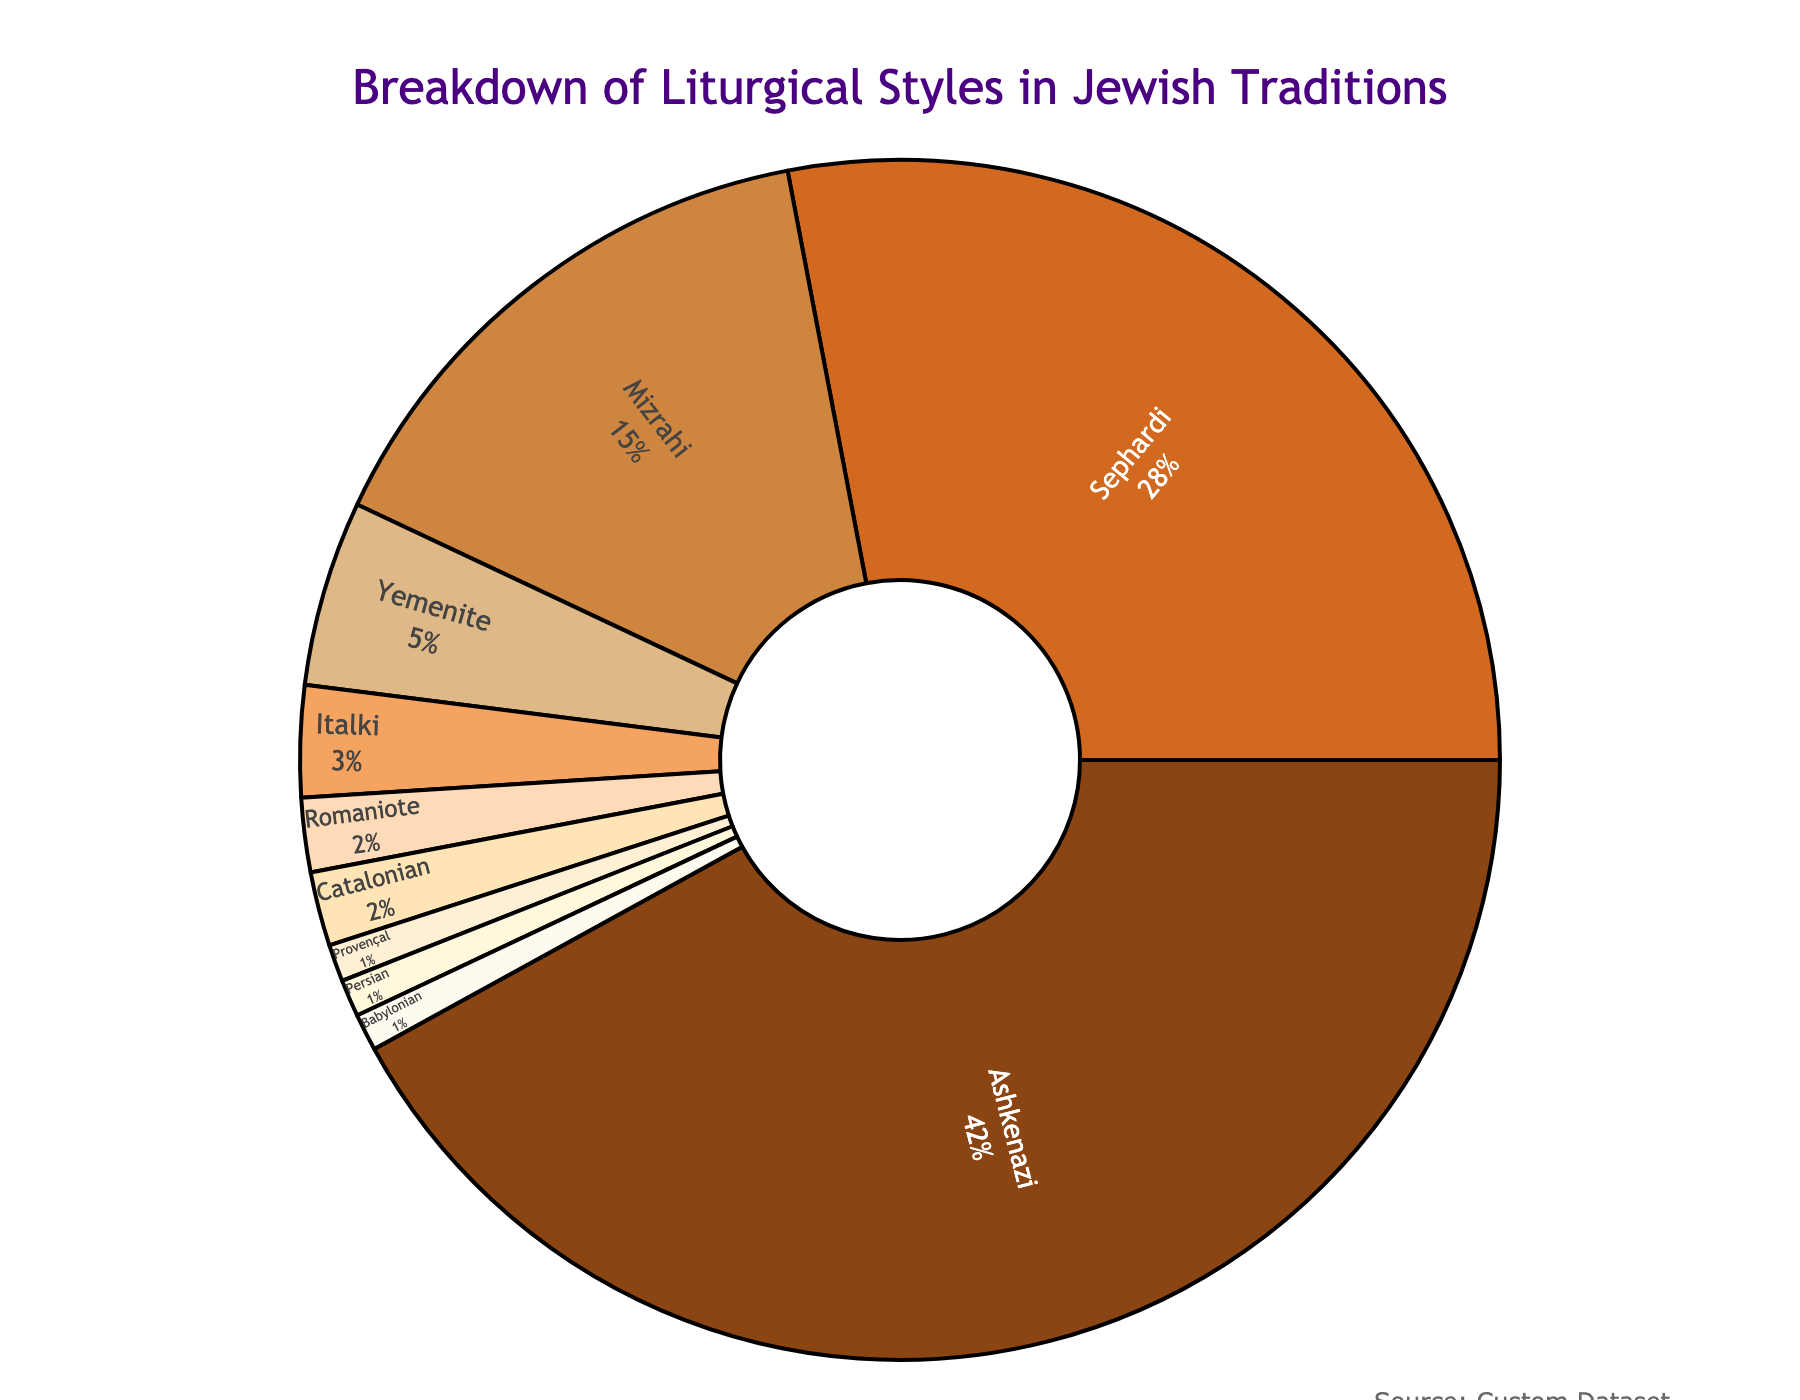Which liturgical style has the highest percentage? The figure shows different segments for each liturgical style, and Ashkenazi occupies the largest segment of the pie chart.
Answer: Ashkenazi What is the combined percentage of Sephardi and Mizrahi traditions? First, find the percentages of Sephardi (28%) and Mizrahi (15%). Add these percentages together: 28% + 15% = 43%.
Answer: 43% Which liturgical styles have percentages of 2% or less? Identify all segments where the percentage is 2% or less: Romaniote (2%), Catalonian (2%), Provençal (1%), Persian (1%), and Babylonian (1%).
Answer: Romaniote, Catalonian, Provençal, Persian, Babylonian How much more prevalent is the Ashkenazi tradition compared to the Yemenite tradition? Subtract the percentage of the Yemenite tradition (5%) from the Ashkenazi tradition (42%): 42% - 5% = 37%.
Answer: 37% What is the total percentage of liturgical styles other than Ashkenazi and Sephardi? First, find the percentages of Ashkenazi (42%) and Sephardi (28%). Add these together to get 70%. Subtract this sum from 100% to find the remainder: 100% - 70% = 30%.
Answer: 30% What is the difference in percentage between the Mizrahi and Yemenite liturgical styles? Subtract the percentage of the Yemenite tradition (5%) from the Mizrahi tradition (15%): 15% - 5% = 10%.
Answer: 10% Compare the percentages of Italki and Persian traditions. Which one is higher and by how much? Italki tradition has 3%, and Persian tradition has 1%. Subtract the smaller percentage from the larger one: 3% - 1% = 2%.
Answer: Italki by 2% What percentage of the liturgical styles in the chart are less than 5% each? Identify all styles with less than 5%: Yemenite (5%), Italki (3%), Romaniote (2%), Catalonian (2%), Provençal (1%), Persian (1%), and Babylonian (1%). Add these percentages: 5% + 3% + 2% + 2% + 1% + 1% + 1% = 15%.
Answer: 15% Which liturgical styles share the same percentage, and what is that percentage? Identify styles with the same segment size. Romaniote and Catalonian both have 2%. Provençal, Persian, and Babylonian each have 1%.
Answer: Romaniote and Catalonian (2%); Provençal, Persian, and Babylonian (1%) 